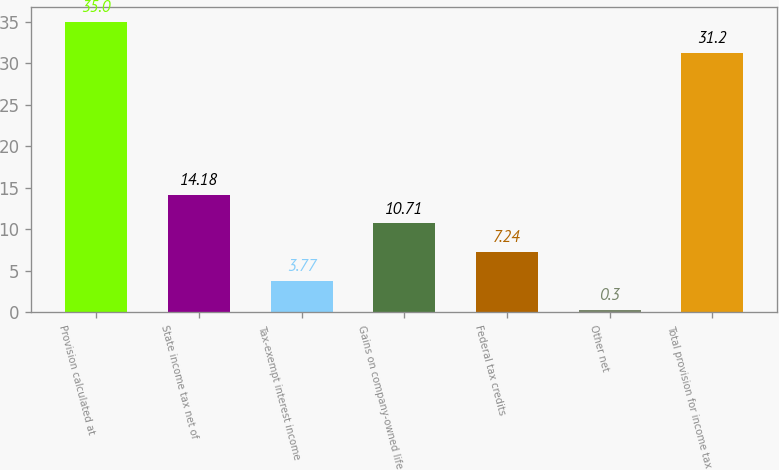Convert chart to OTSL. <chart><loc_0><loc_0><loc_500><loc_500><bar_chart><fcel>Provision calculated at<fcel>State income tax net of<fcel>Tax-exempt interest income<fcel>Gains on company-owned life<fcel>Federal tax credits<fcel>Other net<fcel>Total provision for income tax<nl><fcel>35<fcel>14.18<fcel>3.77<fcel>10.71<fcel>7.24<fcel>0.3<fcel>31.2<nl></chart> 